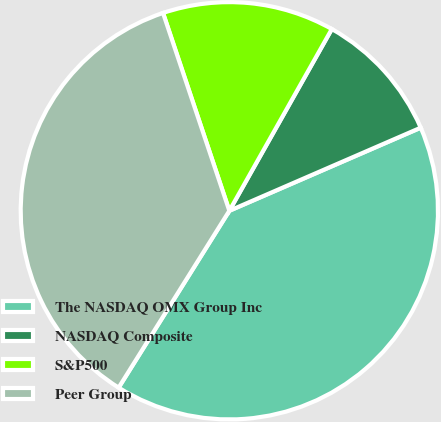<chart> <loc_0><loc_0><loc_500><loc_500><pie_chart><fcel>The NASDAQ OMX Group Inc<fcel>NASDAQ Composite<fcel>S&P500<fcel>Peer Group<nl><fcel>40.42%<fcel>10.31%<fcel>13.32%<fcel>35.95%<nl></chart> 